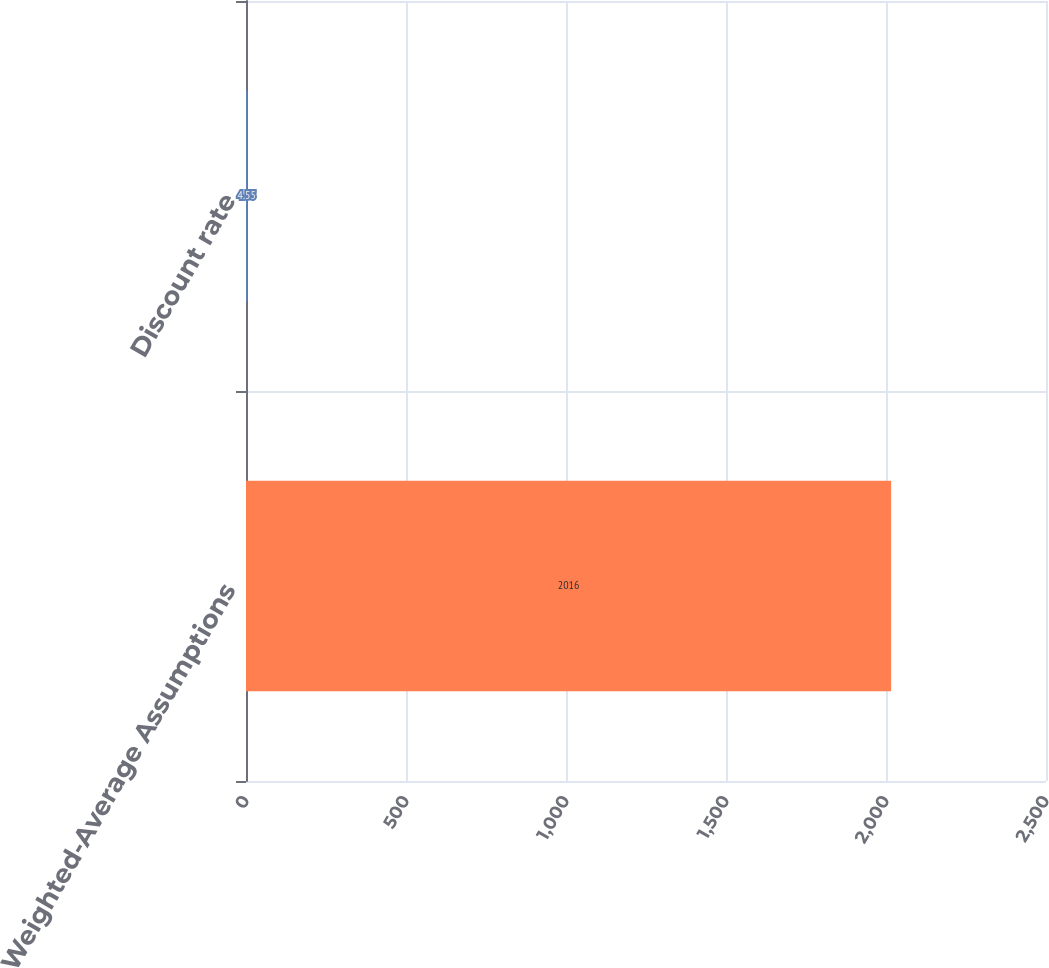Convert chart. <chart><loc_0><loc_0><loc_500><loc_500><bar_chart><fcel>Weighted-Average Assumptions<fcel>Discount rate<nl><fcel>2016<fcel>4.55<nl></chart> 